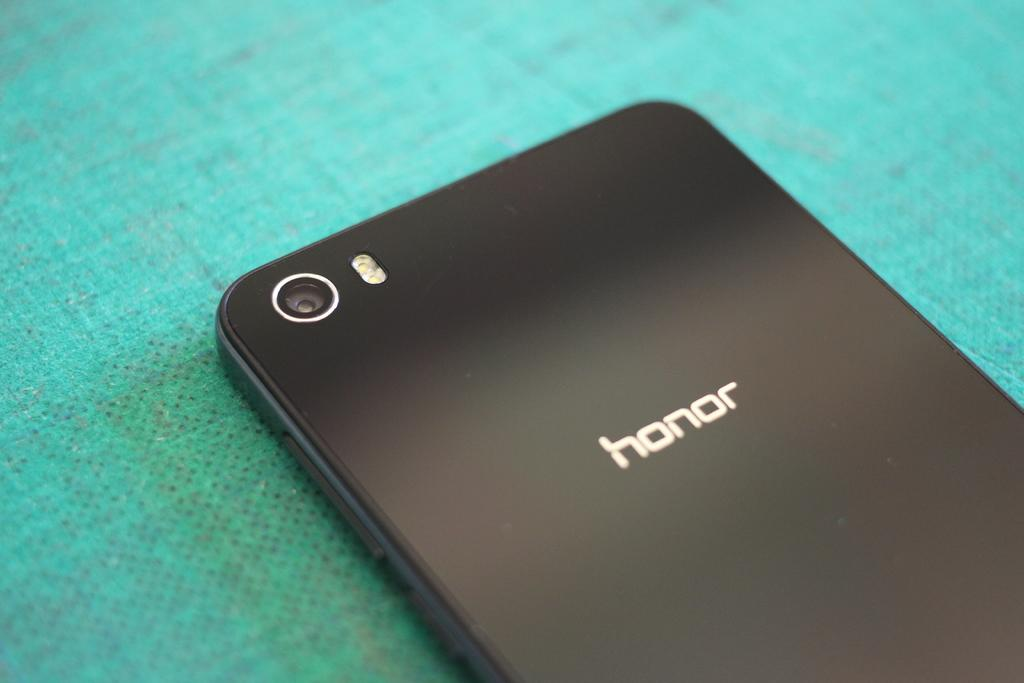<image>
Present a compact description of the photo's key features. An electronic device laying face down that says honor on the back. 